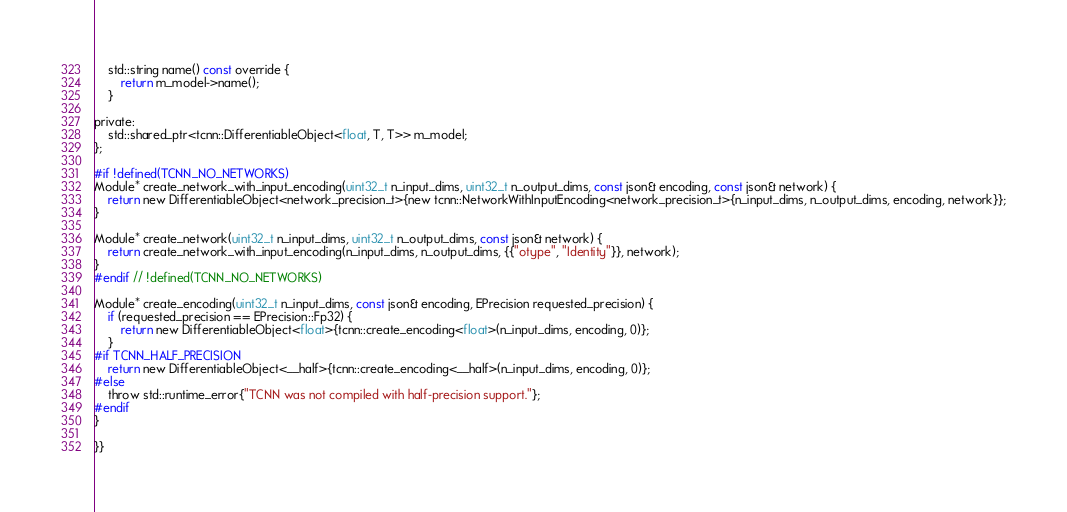<code> <loc_0><loc_0><loc_500><loc_500><_Cuda_>
	std::string name() const override {
		return m_model->name();
	}

private:
	std::shared_ptr<tcnn::DifferentiableObject<float, T, T>> m_model;
};

#if !defined(TCNN_NO_NETWORKS)
Module* create_network_with_input_encoding(uint32_t n_input_dims, uint32_t n_output_dims, const json& encoding, const json& network) {
	return new DifferentiableObject<network_precision_t>{new tcnn::NetworkWithInputEncoding<network_precision_t>{n_input_dims, n_output_dims, encoding, network}};
}

Module* create_network(uint32_t n_input_dims, uint32_t n_output_dims, const json& network) {
	return create_network_with_input_encoding(n_input_dims, n_output_dims, {{"otype", "Identity"}}, network);
}
#endif // !defined(TCNN_NO_NETWORKS)

Module* create_encoding(uint32_t n_input_dims, const json& encoding, EPrecision requested_precision) {
	if (requested_precision == EPrecision::Fp32) {
		return new DifferentiableObject<float>{tcnn::create_encoding<float>(n_input_dims, encoding, 0)};
	}
#if TCNN_HALF_PRECISION
	return new DifferentiableObject<__half>{tcnn::create_encoding<__half>(n_input_dims, encoding, 0)};
#else
	throw std::runtime_error{"TCNN was not compiled with half-precision support."};
#endif
}

}}
</code> 